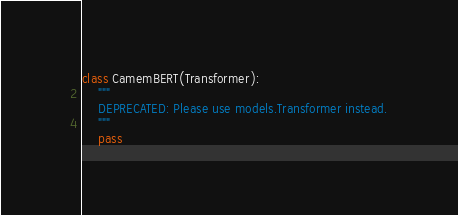<code> <loc_0><loc_0><loc_500><loc_500><_Python_>class CamemBERT(Transformer):
    """
    DEPRECATED: Please use models.Transformer instead.
    """
    pass






</code> 